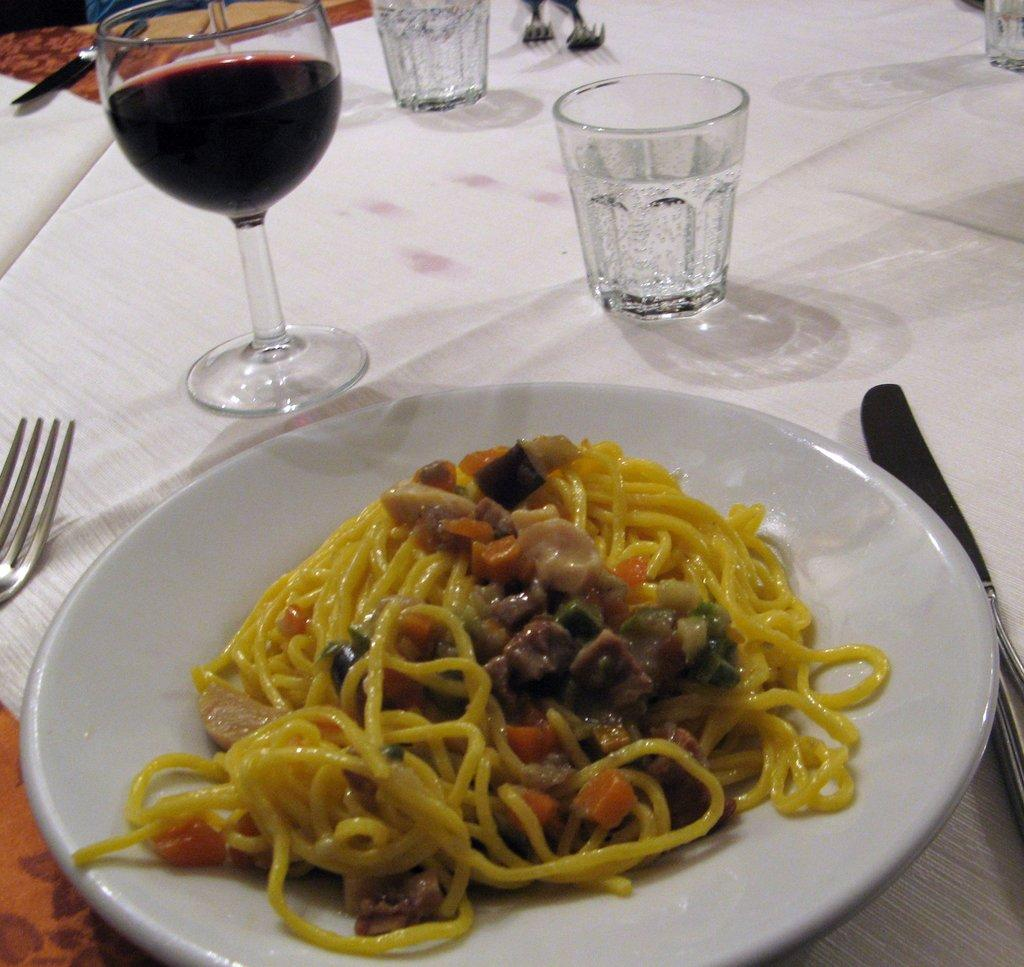What is on the plate in the image? There is food in a plate in the image. What can be found in the glasses in the image? There are glasses with liquid in the image. What utensil is visible in the image? A fork is visible in the image. What other utensil is present in the image? Knives are present in the image. What type of material is covering the table in the image? There is a cloth in the image. Where are all these objects located in the image? All of these objects are placed on a table. What type of insect is crawling on the food in the image? There is no insect present on the food in the image. What flavor of need can be tasted in the liquid in the glasses? There is no mention of a specific flavor or need in the image; it only shows glasses with liquid. 